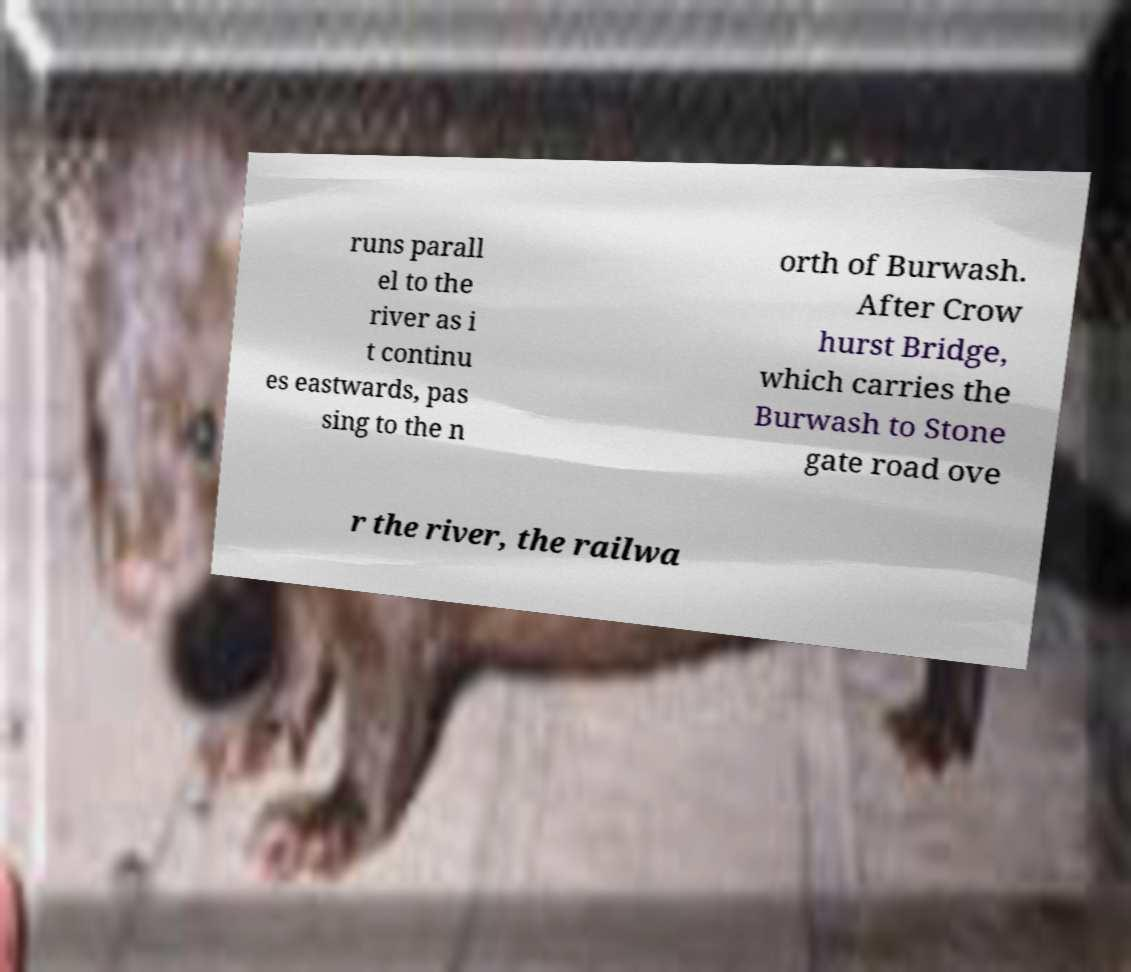For documentation purposes, I need the text within this image transcribed. Could you provide that? runs parall el to the river as i t continu es eastwards, pas sing to the n orth of Burwash. After Crow hurst Bridge, which carries the Burwash to Stone gate road ove r the river, the railwa 